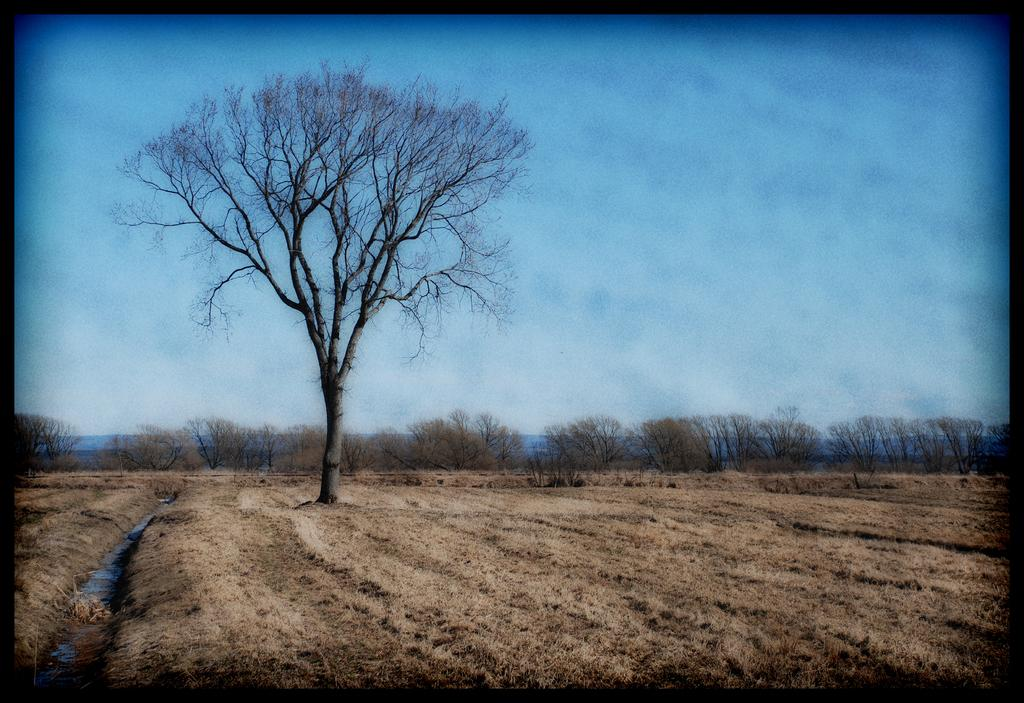What type of vegetation can be seen in the image? There are trees in the image. What is present at the bottom of the image? There is grass at the bottom of the image. How is the grass situated in the image? The grass is on the surface. What can be seen in the background of the image? There are mountains in the background of the image. What is visible at the top of the image? The sky is visible at the top of the image. How many legs can be seen on the tree in the image? Trees do not have legs; they have roots and trunks. In the image, the tree has roots and a trunk, but no legs are visible. 